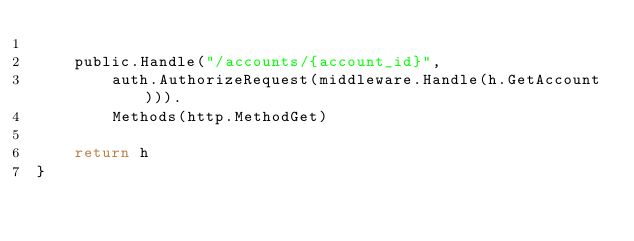<code> <loc_0><loc_0><loc_500><loc_500><_Go_>
	public.Handle("/accounts/{account_id}",
		auth.AuthorizeRequest(middleware.Handle(h.GetAccount))).
		Methods(http.MethodGet)

	return h
}
</code> 